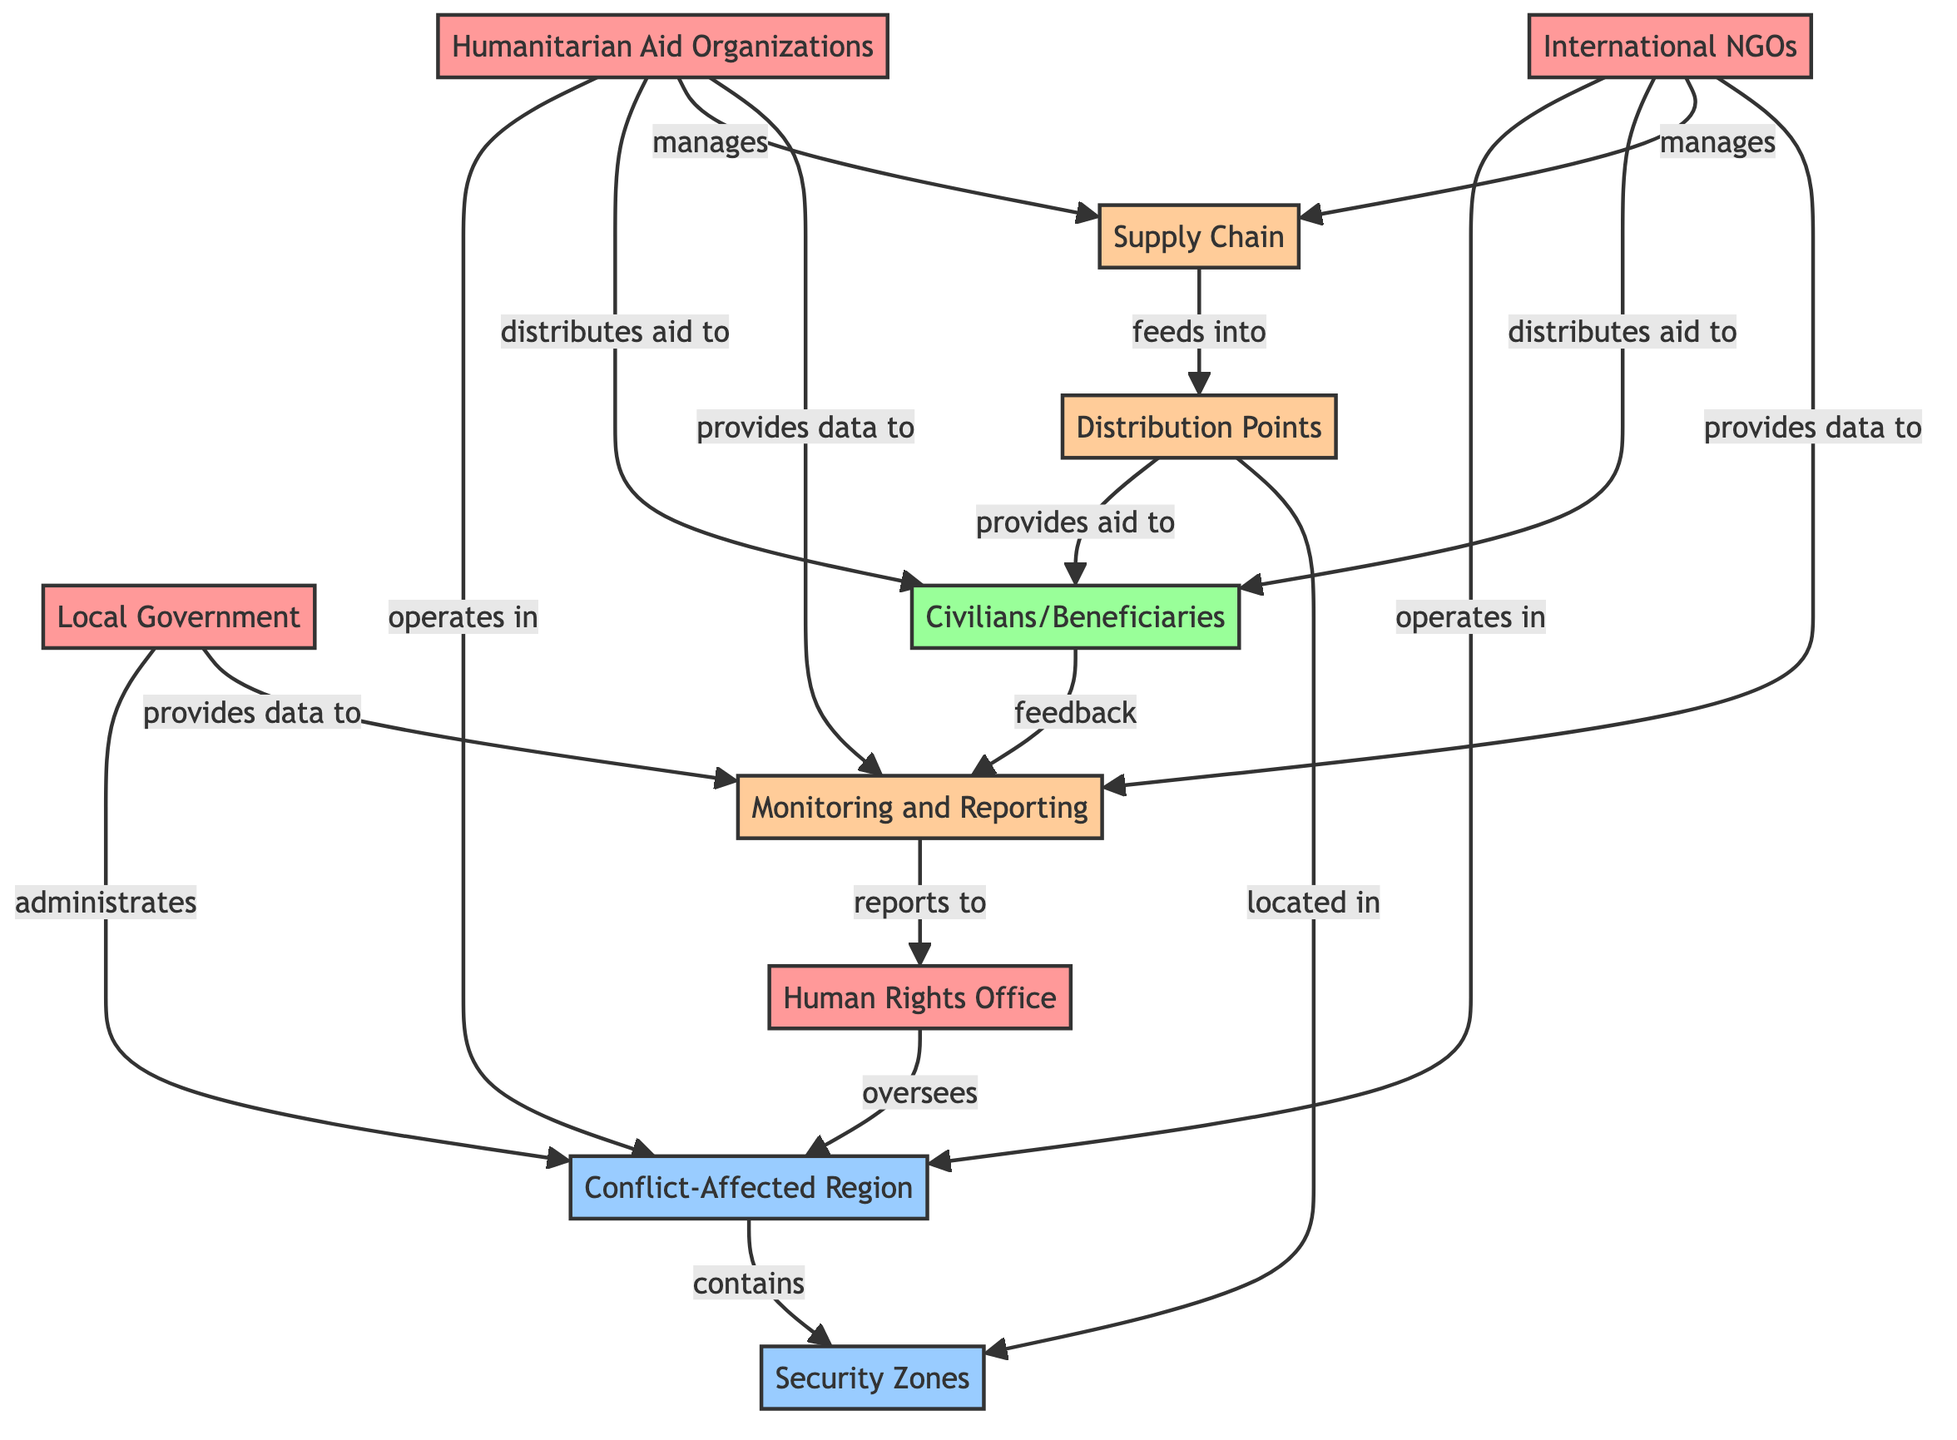What is the total number of nodes in the diagram? The diagram lists 10 distinct entities, each represented as a node, including organizations, geographical areas, individuals, and processes.
Answer: 10 Which organization distributes aid to civilians? The edges indicate that both Humanitarian Aid Organizations and International NGOs have a relationship labeled "distributes aid to" directed towards the node "Civilians/Beneficiaries".
Answer: Humanitarian Aid Organizations and International NGOs What is the relationship between the Human Rights Office and the Conflict-Affected Region? The edge labeled "oversees" connects the Human Rights Office and the Conflict-Affected Region, indicating that the Human Rights Office has a supervisory role over it.
Answer: oversees How many organizations operate in the Conflict-Affected Region? There are three organizations that operate within the Conflict-Affected Region as per the edges connecting to this geographical node: Humanitarian Aid Organizations, International NGOs, and Local Government.
Answer: 3 What process feeds into the Distribution Points? The diagram shows that the Supply Chain feeds into the Distribution Points, as indicated by the directed edge labeled "feeds into".
Answer: Supply Chain Which nodes provide data to the Monitoring and Reporting process? The nodes that provide data to the Monitoring and Reporting process include Local Government, International NGOs, and Humanitarian Aid Organizations as per the respective edges labeled "provides data to".
Answer: Local Government, International NGOs, Humanitarian Aid Organizations How many relationship types are present between the nodes? By analyzing the edges, there are five distinct relationship types: oversees, operates in, distributes aid to, manages, and provides data to. However, each relationship type is counted distinctly, leading to a total of 8 relationships but 5 unique ones.
Answer: 8 What connects the Distribution Points to the Security Zones? The Distribution Points are located in the Security Zones, signified by the edge labeled "located in". This relationship indicates that Distribution Points exist within these geographical areas.
Answer: located in Who receives feedback in the Monitoring and Reporting process? The Civilians/Beneficiaries provide feedback to the Monitoring and Reporting process, as shown by the edge labeled "feedback" directed from Civilians/Beneficiaries to Monitoring and Reporting.
Answer: Civilians/Beneficiaries 